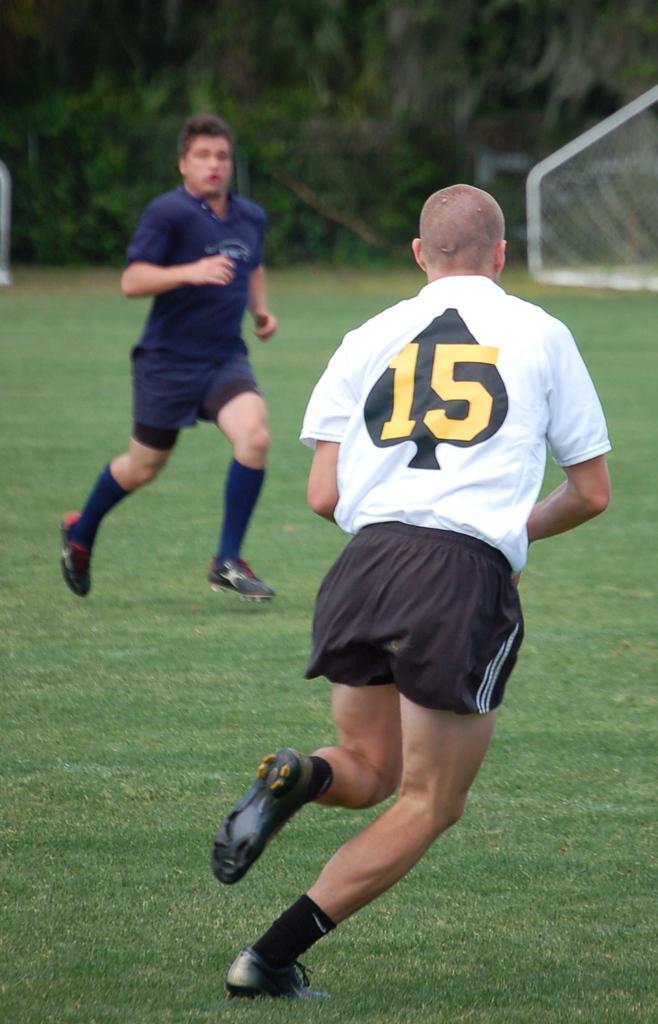Please provide a concise description of this image. In this image I can see there are persons running on the ground. And there is a grass, Trees and a net. 